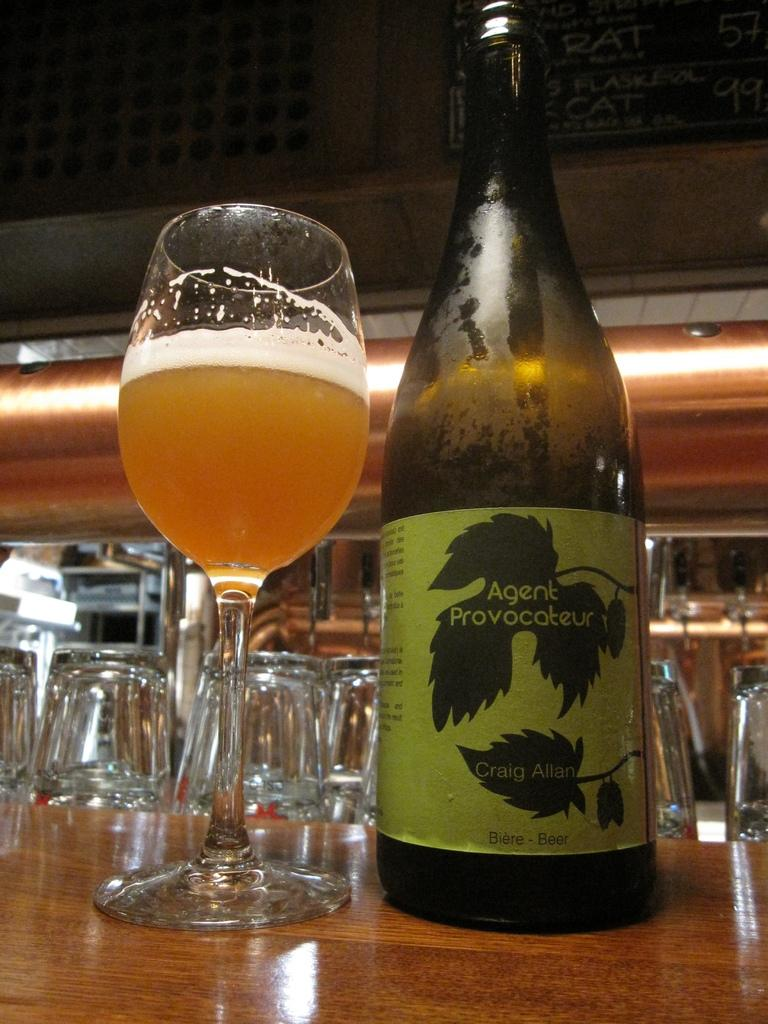<image>
Relay a brief, clear account of the picture shown. A bottle of Agent Provocateur next to a half full glass. 